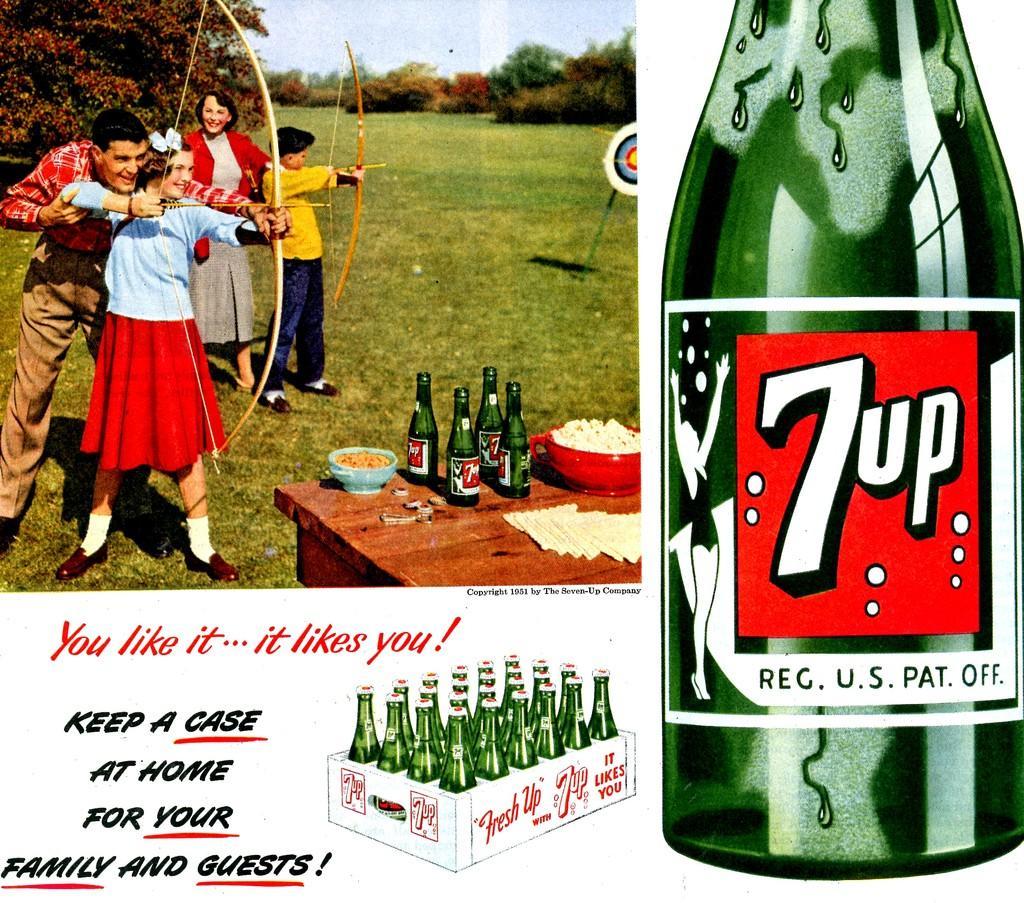Can you describe this image briefly? In this image I can see four people were two of them are holding bow and arrow. On this table I can see number of bottles and food in bowls. In the background I can see a board and number of trees. 